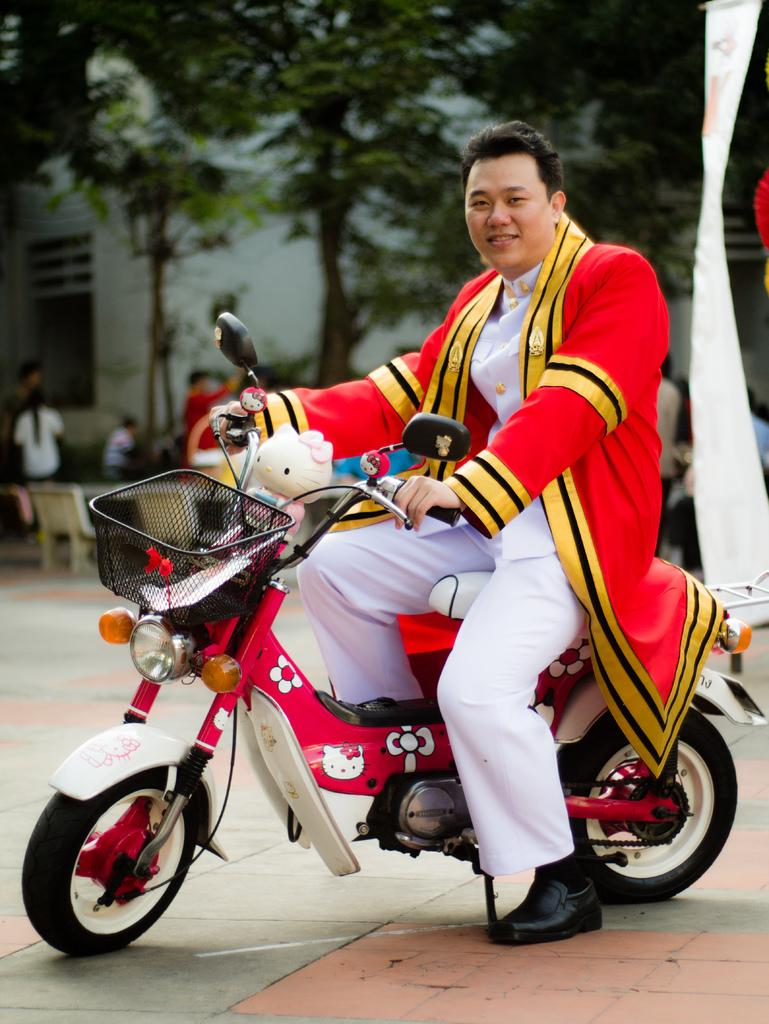What is the person in the image doing? The person is sitting on a bike. How is the person interacting with the bike? The person is holding the bike. What can be seen in the background of the image? There is a wall and a tree in the background of the image. Are there any other people visible in the image? Yes, there are a few people in the distance. Where is the setting of the image? The setting is on a road. What type of cast is the person wearing on their leg in the image? There is no cast visible on the person's leg in the image. What role does the person play in the event depicted in the image? There is no event depicted in the image, so it is not possible to determine the person's role. 